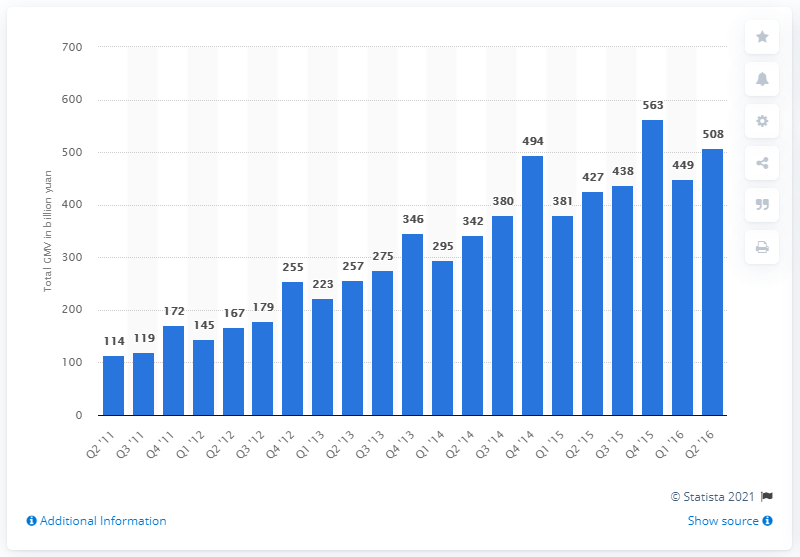Specify some key components in this picture. In the last quarter of 2016, Taobao's Gross Merchandise Volume (GMV) was approximately 508. 